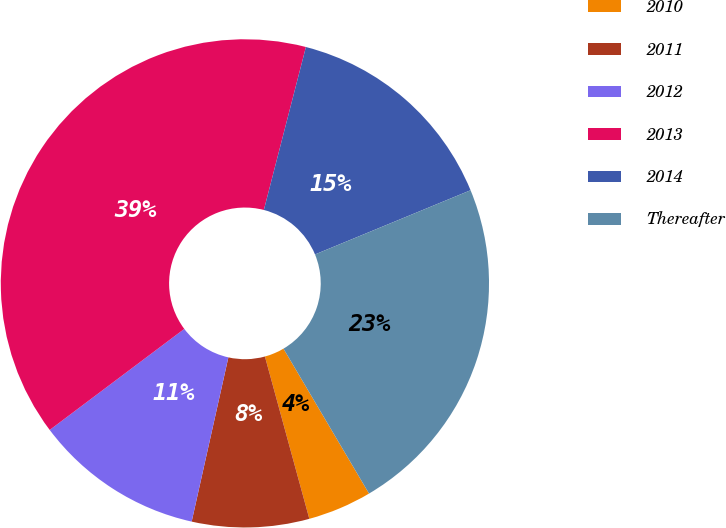Convert chart. <chart><loc_0><loc_0><loc_500><loc_500><pie_chart><fcel>2010<fcel>2011<fcel>2012<fcel>2013<fcel>2014<fcel>Thereafter<nl><fcel>4.24%<fcel>7.75%<fcel>11.25%<fcel>39.27%<fcel>14.75%<fcel>22.74%<nl></chart> 